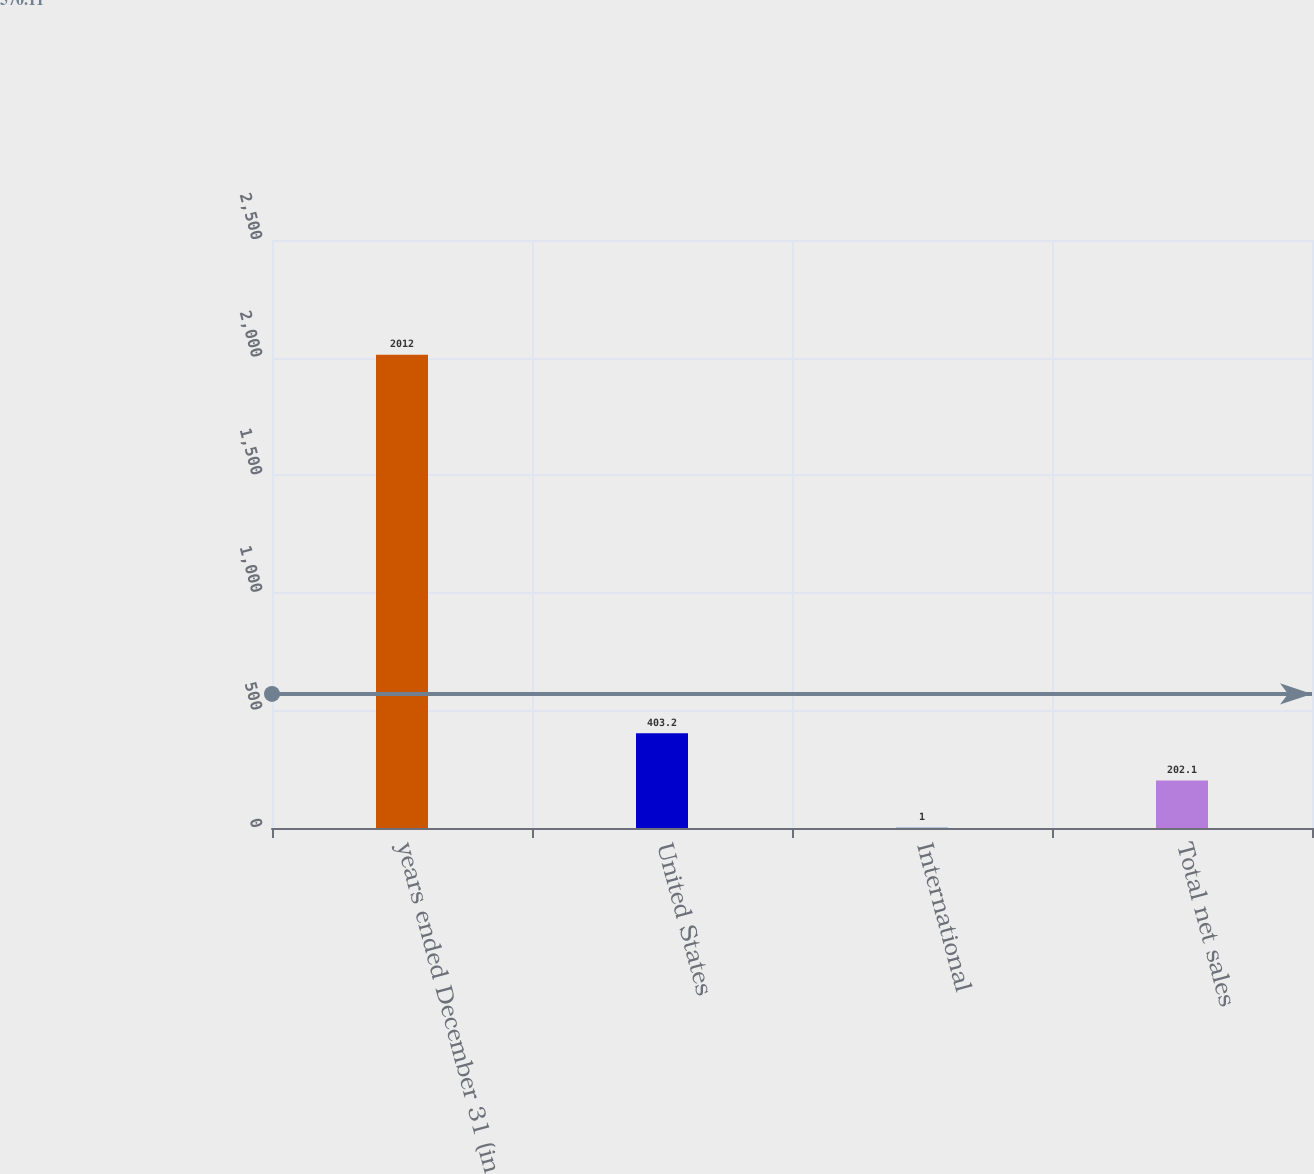Convert chart to OTSL. <chart><loc_0><loc_0><loc_500><loc_500><bar_chart><fcel>years ended December 31 (in<fcel>United States<fcel>International<fcel>Total net sales<nl><fcel>2012<fcel>403.2<fcel>1<fcel>202.1<nl></chart> 